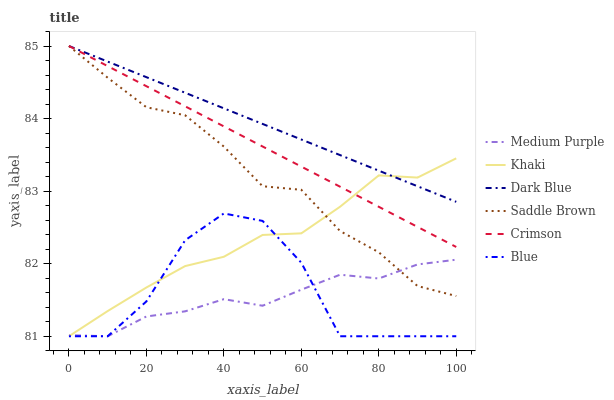Does Medium Purple have the minimum area under the curve?
Answer yes or no. Yes. Does Dark Blue have the maximum area under the curve?
Answer yes or no. Yes. Does Khaki have the minimum area under the curve?
Answer yes or no. No. Does Khaki have the maximum area under the curve?
Answer yes or no. No. Is Dark Blue the smoothest?
Answer yes or no. Yes. Is Blue the roughest?
Answer yes or no. Yes. Is Khaki the smoothest?
Answer yes or no. No. Is Khaki the roughest?
Answer yes or no. No. Does Dark Blue have the lowest value?
Answer yes or no. No. Does Saddle Brown have the highest value?
Answer yes or no. Yes. Does Khaki have the highest value?
Answer yes or no. No. Is Blue less than Crimson?
Answer yes or no. Yes. Is Crimson greater than Medium Purple?
Answer yes or no. Yes. Does Dark Blue intersect Crimson?
Answer yes or no. Yes. Is Dark Blue less than Crimson?
Answer yes or no. No. Is Dark Blue greater than Crimson?
Answer yes or no. No. Does Blue intersect Crimson?
Answer yes or no. No. 